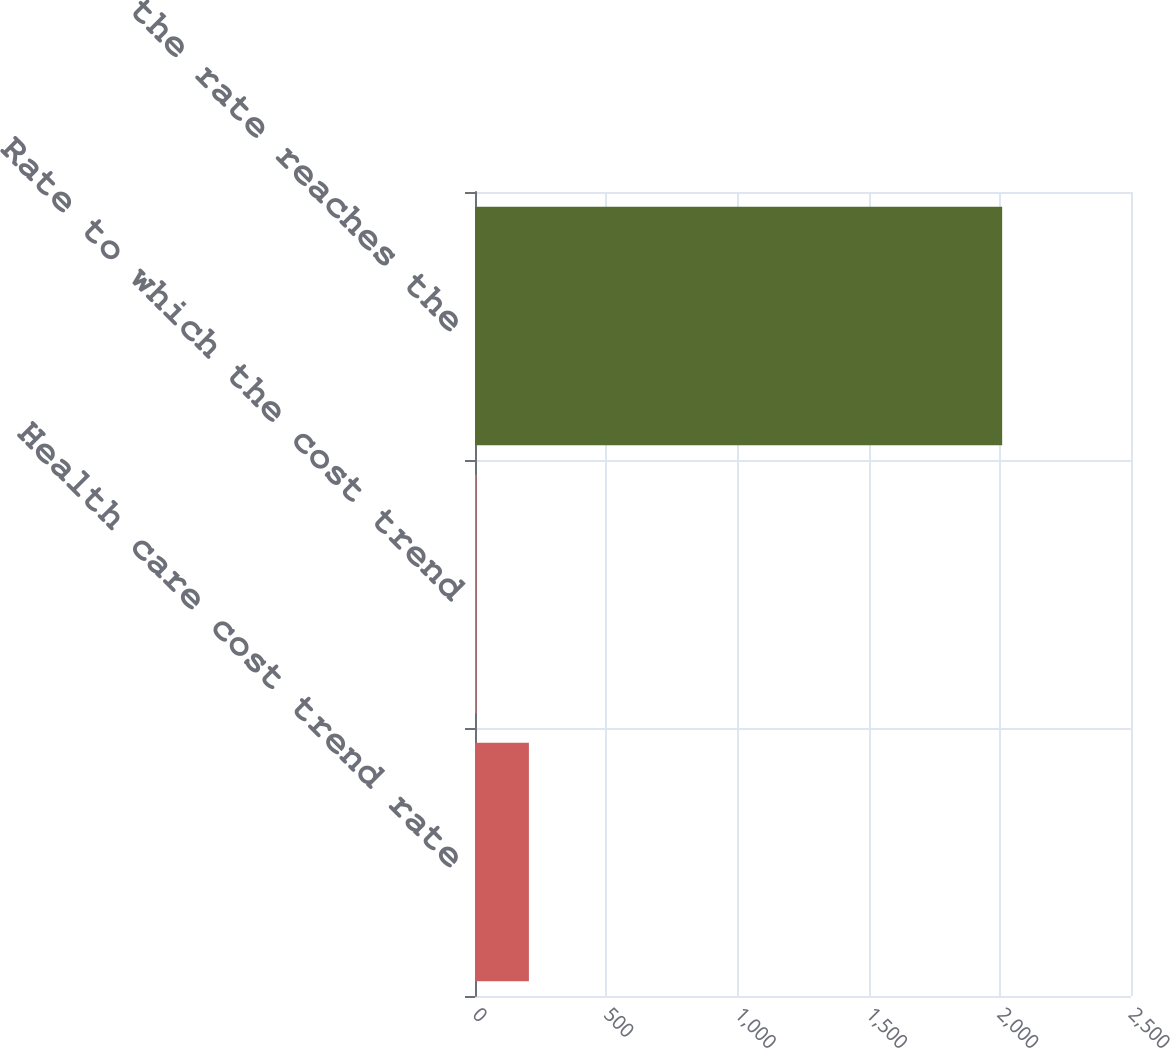Convert chart to OTSL. <chart><loc_0><loc_0><loc_500><loc_500><bar_chart><fcel>Health care cost trend rate<fcel>Rate to which the cost trend<fcel>Year that the rate reaches the<nl><fcel>205.4<fcel>5<fcel>2009<nl></chart> 